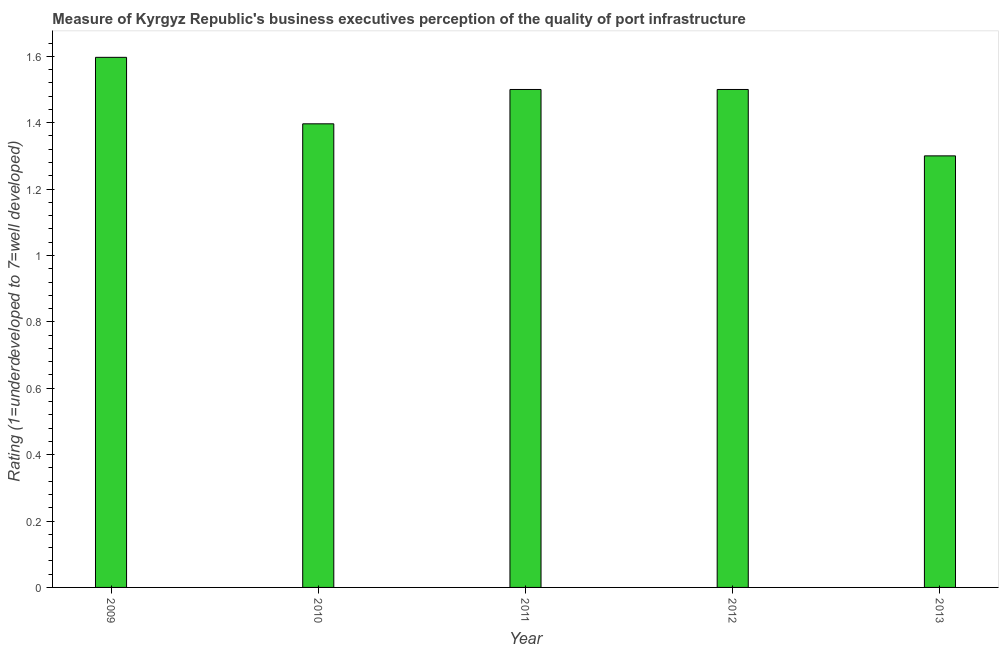Does the graph contain any zero values?
Provide a succinct answer. No. What is the title of the graph?
Make the answer very short. Measure of Kyrgyz Republic's business executives perception of the quality of port infrastructure. What is the label or title of the X-axis?
Provide a succinct answer. Year. What is the label or title of the Y-axis?
Your response must be concise. Rating (1=underdeveloped to 7=well developed) . What is the rating measuring quality of port infrastructure in 2009?
Give a very brief answer. 1.6. Across all years, what is the maximum rating measuring quality of port infrastructure?
Make the answer very short. 1.6. Across all years, what is the minimum rating measuring quality of port infrastructure?
Offer a very short reply. 1.3. What is the sum of the rating measuring quality of port infrastructure?
Give a very brief answer. 7.29. What is the difference between the rating measuring quality of port infrastructure in 2009 and 2013?
Give a very brief answer. 0.3. What is the average rating measuring quality of port infrastructure per year?
Ensure brevity in your answer.  1.46. What is the median rating measuring quality of port infrastructure?
Make the answer very short. 1.5. In how many years, is the rating measuring quality of port infrastructure greater than 1.44 ?
Your answer should be compact. 3. What is the ratio of the rating measuring quality of port infrastructure in 2011 to that in 2013?
Your answer should be compact. 1.15. Is the rating measuring quality of port infrastructure in 2011 less than that in 2012?
Provide a succinct answer. No. What is the difference between the highest and the second highest rating measuring quality of port infrastructure?
Offer a very short reply. 0.1. Is the sum of the rating measuring quality of port infrastructure in 2010 and 2011 greater than the maximum rating measuring quality of port infrastructure across all years?
Give a very brief answer. Yes. How many bars are there?
Offer a very short reply. 5. What is the difference between two consecutive major ticks on the Y-axis?
Offer a very short reply. 0.2. What is the Rating (1=underdeveloped to 7=well developed)  of 2009?
Your response must be concise. 1.6. What is the Rating (1=underdeveloped to 7=well developed)  in 2010?
Give a very brief answer. 1.4. What is the Rating (1=underdeveloped to 7=well developed)  of 2011?
Offer a very short reply. 1.5. What is the Rating (1=underdeveloped to 7=well developed)  of 2012?
Make the answer very short. 1.5. What is the difference between the Rating (1=underdeveloped to 7=well developed)  in 2009 and 2010?
Provide a succinct answer. 0.2. What is the difference between the Rating (1=underdeveloped to 7=well developed)  in 2009 and 2011?
Keep it short and to the point. 0.1. What is the difference between the Rating (1=underdeveloped to 7=well developed)  in 2009 and 2012?
Your response must be concise. 0.1. What is the difference between the Rating (1=underdeveloped to 7=well developed)  in 2009 and 2013?
Make the answer very short. 0.3. What is the difference between the Rating (1=underdeveloped to 7=well developed)  in 2010 and 2011?
Your answer should be very brief. -0.1. What is the difference between the Rating (1=underdeveloped to 7=well developed)  in 2010 and 2012?
Keep it short and to the point. -0.1. What is the difference between the Rating (1=underdeveloped to 7=well developed)  in 2010 and 2013?
Provide a short and direct response. 0.1. What is the difference between the Rating (1=underdeveloped to 7=well developed)  in 2011 and 2013?
Make the answer very short. 0.2. What is the ratio of the Rating (1=underdeveloped to 7=well developed)  in 2009 to that in 2010?
Offer a very short reply. 1.14. What is the ratio of the Rating (1=underdeveloped to 7=well developed)  in 2009 to that in 2011?
Provide a short and direct response. 1.06. What is the ratio of the Rating (1=underdeveloped to 7=well developed)  in 2009 to that in 2012?
Offer a very short reply. 1.06. What is the ratio of the Rating (1=underdeveloped to 7=well developed)  in 2009 to that in 2013?
Provide a short and direct response. 1.23. What is the ratio of the Rating (1=underdeveloped to 7=well developed)  in 2010 to that in 2011?
Offer a terse response. 0.93. What is the ratio of the Rating (1=underdeveloped to 7=well developed)  in 2010 to that in 2012?
Provide a short and direct response. 0.93. What is the ratio of the Rating (1=underdeveloped to 7=well developed)  in 2010 to that in 2013?
Your answer should be compact. 1.07. What is the ratio of the Rating (1=underdeveloped to 7=well developed)  in 2011 to that in 2012?
Offer a very short reply. 1. What is the ratio of the Rating (1=underdeveloped to 7=well developed)  in 2011 to that in 2013?
Your answer should be compact. 1.15. What is the ratio of the Rating (1=underdeveloped to 7=well developed)  in 2012 to that in 2013?
Ensure brevity in your answer.  1.15. 